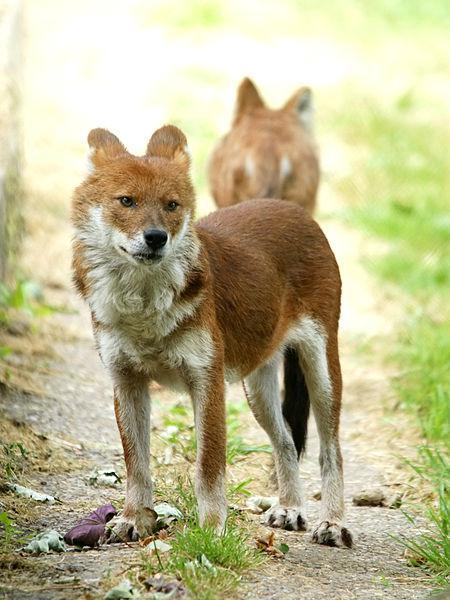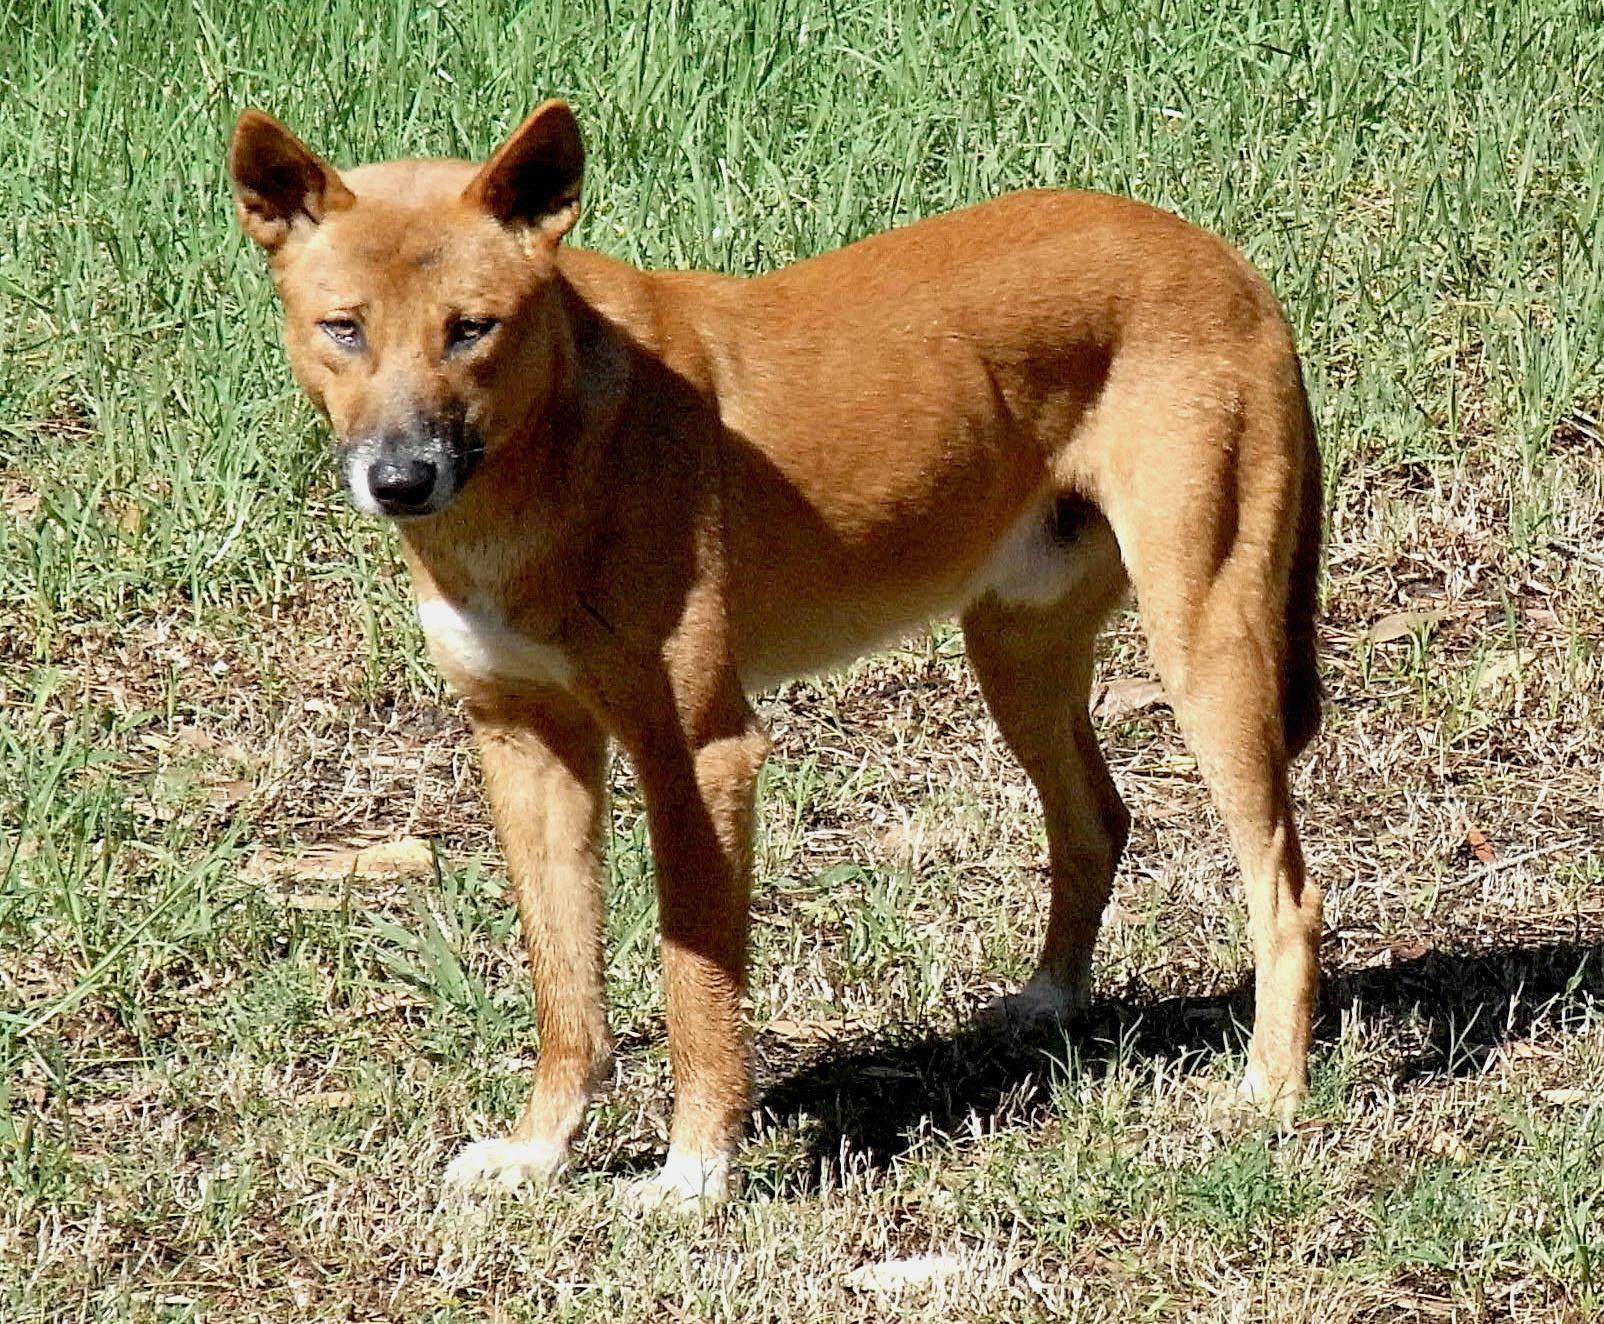The first image is the image on the left, the second image is the image on the right. Given the left and right images, does the statement "There are two dogs" hold true? Answer yes or no. No. The first image is the image on the left, the second image is the image on the right. Evaluate the accuracy of this statement regarding the images: "Left image shows two dogs and right image shows one dog.". Is it true? Answer yes or no. Yes. 